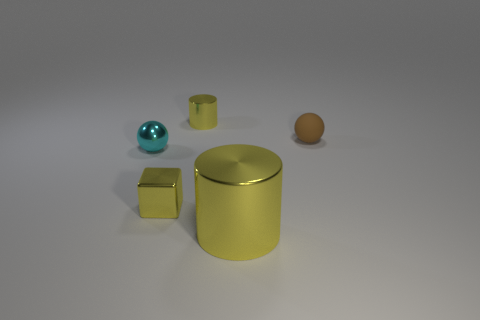Add 4 tiny yellow cylinders. How many objects exist? 9 Subtract 0 red cubes. How many objects are left? 5 Subtract all spheres. How many objects are left? 3 Subtract 1 blocks. How many blocks are left? 0 Subtract all red cubes. Subtract all brown balls. How many cubes are left? 1 Subtract all yellow cylinders. How many red cubes are left? 0 Subtract all tiny blue balls. Subtract all small metallic spheres. How many objects are left? 4 Add 3 cyan metal things. How many cyan metal things are left? 4 Add 5 brown spheres. How many brown spheres exist? 6 